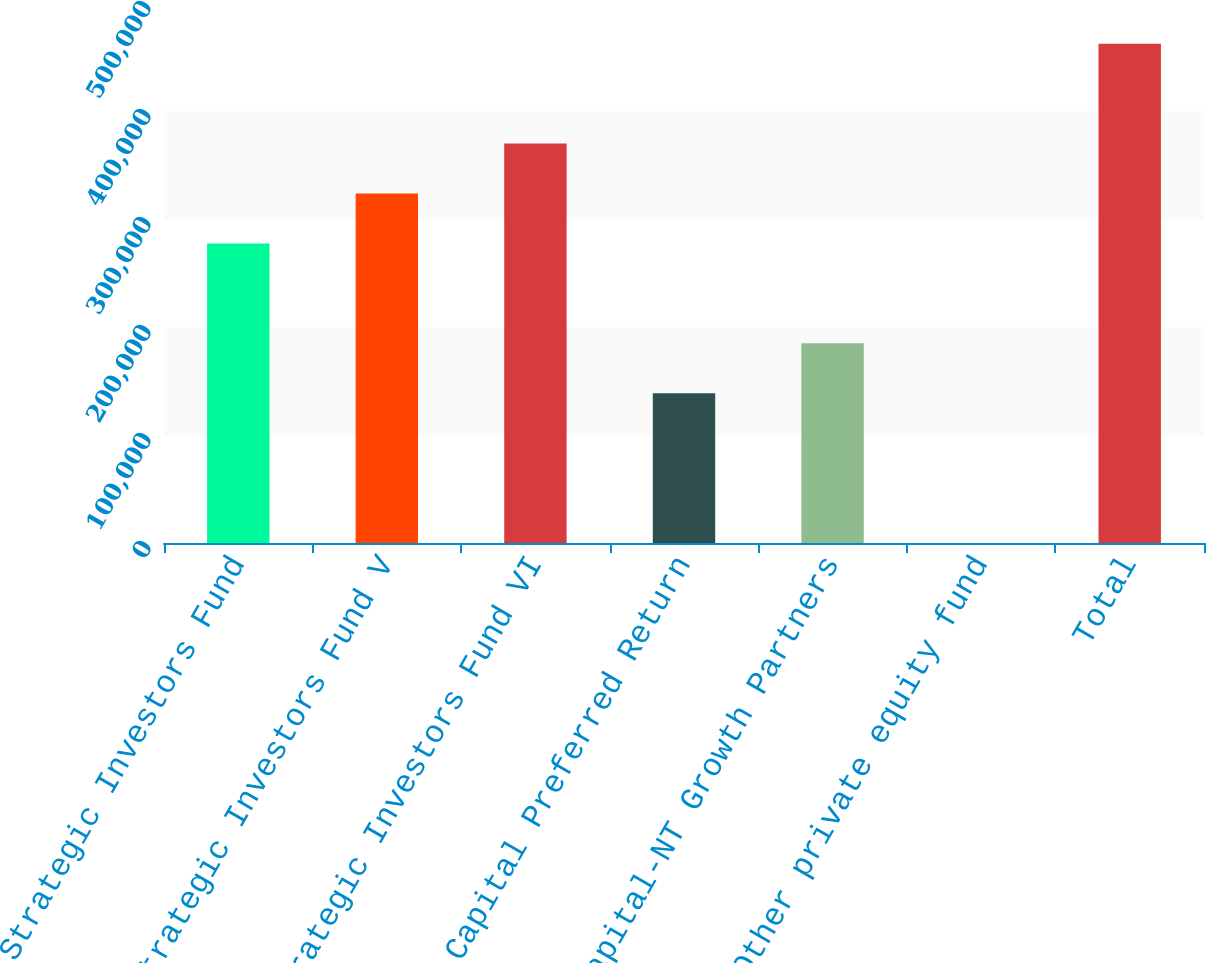Convert chart. <chart><loc_0><loc_0><loc_500><loc_500><bar_chart><fcel>SVB Strategic Investors Fund<fcel>Strategic Investors Fund V<fcel>Strategic Investors Fund VI<fcel>SVB Capital Preferred Return<fcel>SVB Capital-NT Growth Partners<fcel>Other private equity fund<fcel>Total<nl><fcel>277419<fcel>323643<fcel>369867<fcel>138748<fcel>184972<fcel>77<fcel>462314<nl></chart> 